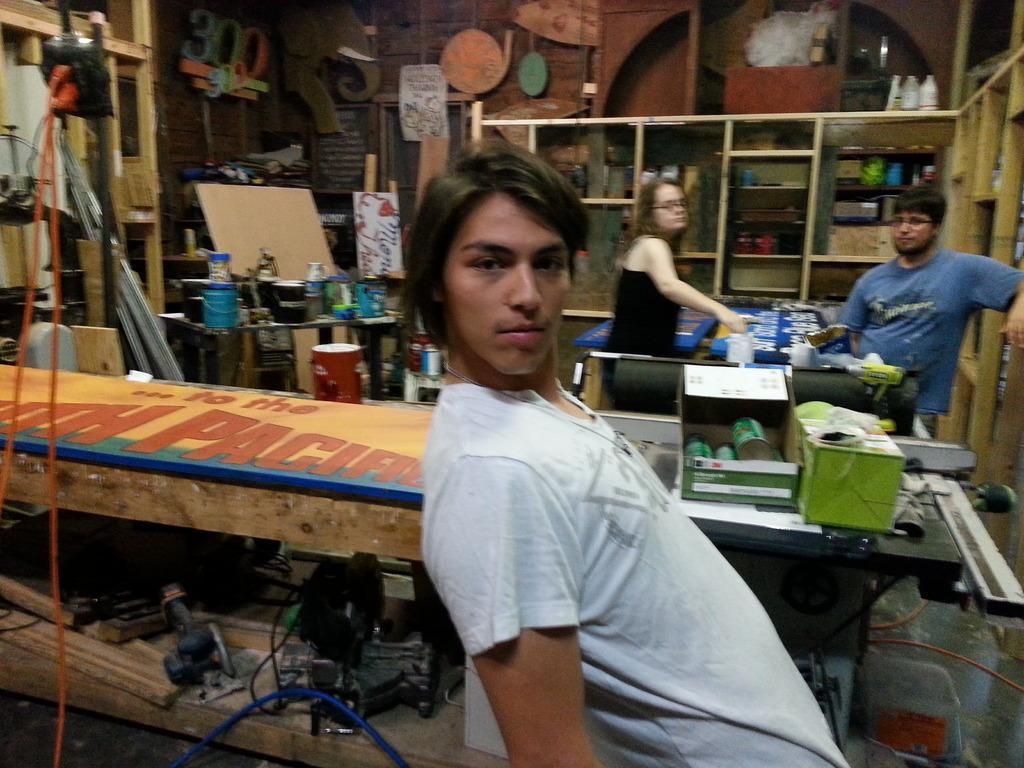Please provide a concise description of this image. In this image we can see two men and a woman. In the background of the image there is a rack in which there are many objects. There is a wall on which there are posters and boards. There are bottles. In the center of the image there is a wooden table with some text on it. There is a machine. There are wires. At the bottom of the image there is floor. 